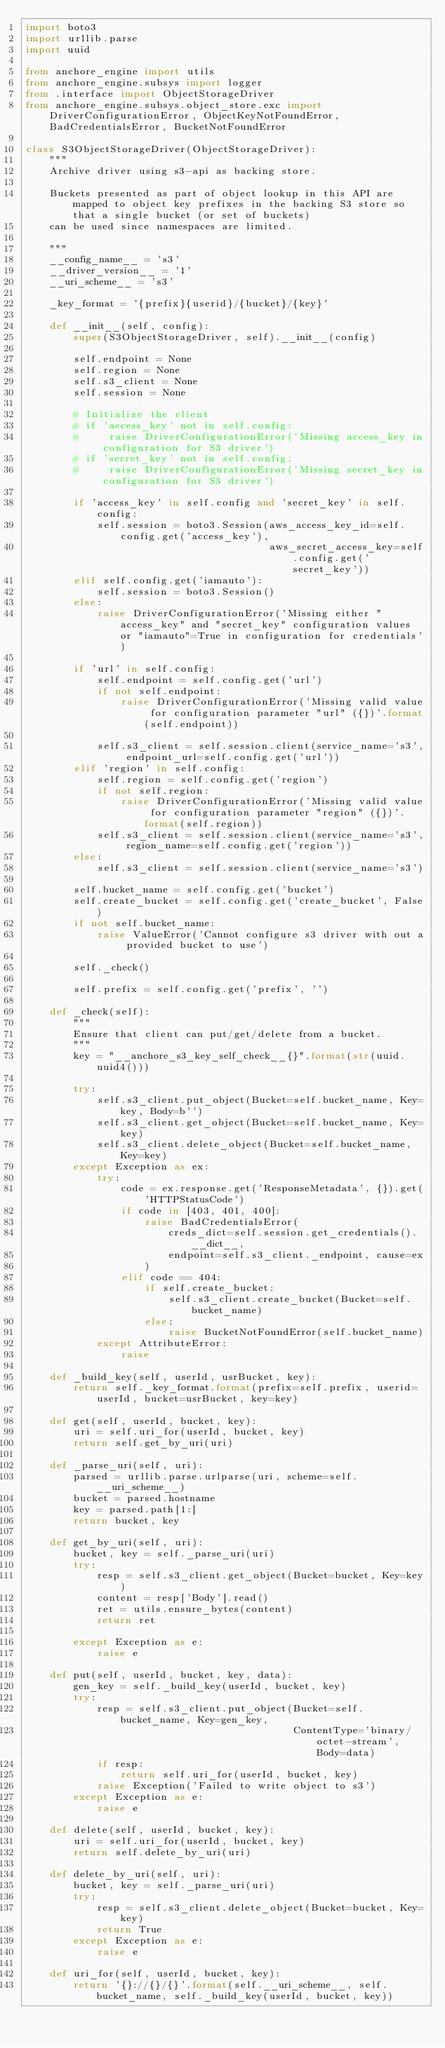<code> <loc_0><loc_0><loc_500><loc_500><_Python_>import boto3
import urllib.parse
import uuid

from anchore_engine import utils
from anchore_engine.subsys import logger
from .interface import ObjectStorageDriver
from anchore_engine.subsys.object_store.exc import DriverConfigurationError, ObjectKeyNotFoundError, BadCredentialsError, BucketNotFoundError

class S3ObjectStorageDriver(ObjectStorageDriver):
    """
    Archive driver using s3-api as backing store.

    Buckets presented as part of object lookup in this API are mapped to object key prefixes in the backing S3 store so that a single bucket (or set of buckets)
    can be used since namespaces are limited.

    """
    __config_name__ = 's3'
    __driver_version__ = '1'
    __uri_scheme__ = 's3'

    _key_format = '{prefix}{userid}/{bucket}/{key}'

    def __init__(self, config):
        super(S3ObjectStorageDriver, self).__init__(config)

        self.endpoint = None
        self.region = None
        self.s3_client = None
        self.session = None

        # Initialize the client
        # if 'access_key' not in self.config:
        #     raise DriverConfigurationError('Missing access_key in configuration for S3 driver')
        # if 'secret_key' not in self.config:
        #     raise DriverConfigurationError('Missing secret_key in configuration for S3 driver')

        if 'access_key' in self.config and 'secret_key' in self.config:
            self.session = boto3.Session(aws_access_key_id=self.config.get('access_key'),
                                         aws_secret_access_key=self.config.get('secret_key'))
        elif self.config.get('iamauto'):
            self.session = boto3.Session()
        else:
            raise DriverConfigurationError('Missing either "access_key" and "secret_key" configuration values or "iamauto"=True in configuration for credentials')

        if 'url' in self.config:
            self.endpoint = self.config.get('url')
            if not self.endpoint:
                raise DriverConfigurationError('Missing valid value for configuration parameter "url" ({})'.format(self.endpoint))

            self.s3_client = self.session.client(service_name='s3', endpoint_url=self.config.get('url'))
        elif 'region' in self.config:
            self.region = self.config.get('region')
            if not self.region:
                raise DriverConfigurationError('Missing valid value for configuration parameter "region" ({})'.format(self.region))
            self.s3_client = self.session.client(service_name='s3', region_name=self.config.get('region'))
        else:
            self.s3_client = self.session.client(service_name='s3')

        self.bucket_name = self.config.get('bucket')
        self.create_bucket = self.config.get('create_bucket', False)
        if not self.bucket_name:
            raise ValueError('Cannot configure s3 driver with out a provided bucket to use')

        self._check()

        self.prefix = self.config.get('prefix', '')

    def _check(self):
        """
        Ensure that client can put/get/delete from a bucket.
        """
        key = "__anchore_s3_key_self_check__{}".format(str(uuid.uuid4()))

        try:
            self.s3_client.put_object(Bucket=self.bucket_name, Key=key, Body=b'')
            self.s3_client.get_object(Bucket=self.bucket_name, Key=key)
            self.s3_client.delete_object(Bucket=self.bucket_name, Key=key)
        except Exception as ex:
            try:
                code = ex.response.get('ResponseMetadata', {}).get('HTTPStatusCode')
                if code in [403, 401, 400]:
                    raise BadCredentialsError(
                        creds_dict=self.session.get_credentials().__dict__,
                        endpoint=self.s3_client._endpoint, cause=ex
                    )
                elif code == 404:
                    if self.create_bucket:
                        self.s3_client.create_bucket(Bucket=self.bucket_name)
                    else:
                        raise BucketNotFoundError(self.bucket_name)
            except AttributeError:
                raise

    def _build_key(self, userId, usrBucket, key):
        return self._key_format.format(prefix=self.prefix, userid=userId, bucket=usrBucket, key=key)

    def get(self, userId, bucket, key):
        uri = self.uri_for(userId, bucket, key)
        return self.get_by_uri(uri)

    def _parse_uri(self, uri):
        parsed = urllib.parse.urlparse(uri, scheme=self.__uri_scheme__)
        bucket = parsed.hostname
        key = parsed.path[1:]
        return bucket, key

    def get_by_uri(self, uri):
        bucket, key = self._parse_uri(uri)
        try:
            resp = self.s3_client.get_object(Bucket=bucket, Key=key)
            content = resp['Body'].read()
            ret = utils.ensure_bytes(content)
            return ret

        except Exception as e:
            raise e

    def put(self, userId, bucket, key, data):
        gen_key = self._build_key(userId, bucket, key)
        try:
            resp = self.s3_client.put_object(Bucket=self.bucket_name, Key=gen_key,
                                             ContentType='binary/octet-stream', Body=data)
            if resp:
                return self.uri_for(userId, bucket, key)
            raise Exception('Failed to write object to s3')
        except Exception as e:
            raise e

    def delete(self, userId, bucket, key):
        uri = self.uri_for(userId, bucket, key)
        return self.delete_by_uri(uri)

    def delete_by_uri(self, uri):
        bucket, key = self._parse_uri(uri)
        try:
            resp = self.s3_client.delete_object(Bucket=bucket, Key=key)
            return True
        except Exception as e:
            raise e

    def uri_for(self, userId, bucket, key):
        return '{}://{}/{}'.format(self.__uri_scheme__, self.bucket_name, self._build_key(userId, bucket, key))
</code> 